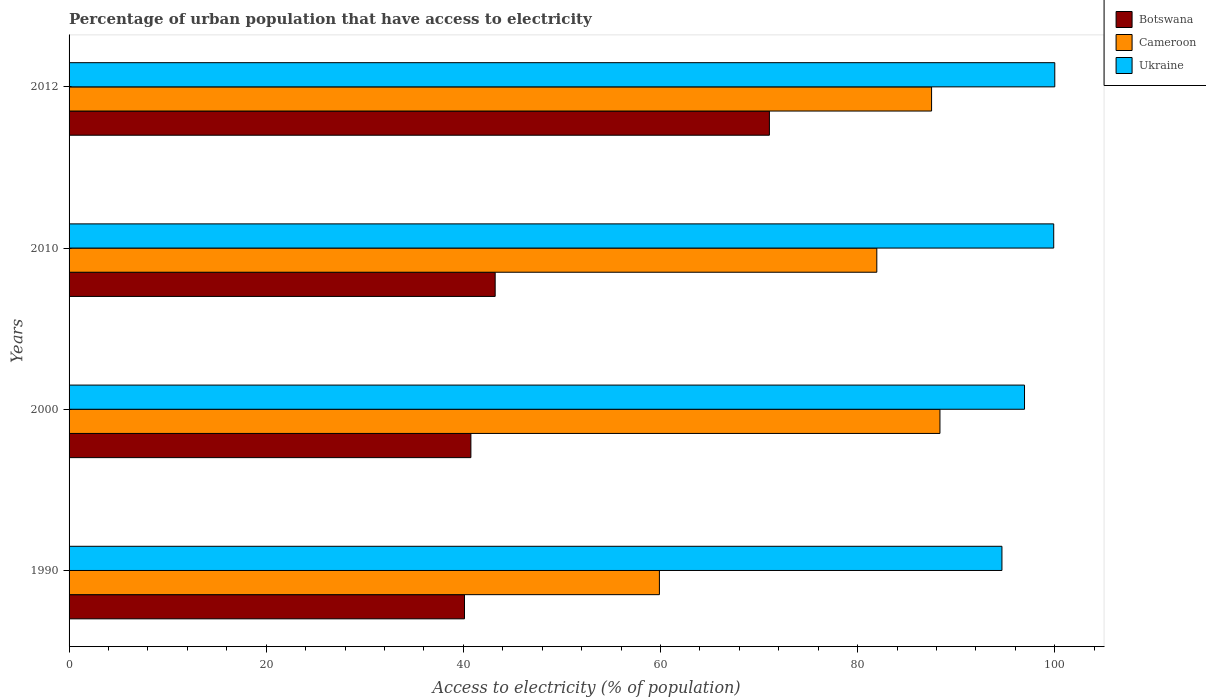Are the number of bars on each tick of the Y-axis equal?
Offer a very short reply. Yes. How many bars are there on the 3rd tick from the top?
Provide a short and direct response. 3. How many bars are there on the 4th tick from the bottom?
Offer a very short reply. 3. What is the percentage of urban population that have access to electricity in Botswana in 2012?
Offer a very short reply. 71.05. Across all years, what is the maximum percentage of urban population that have access to electricity in Botswana?
Provide a short and direct response. 71.05. Across all years, what is the minimum percentage of urban population that have access to electricity in Ukraine?
Offer a very short reply. 94.64. In which year was the percentage of urban population that have access to electricity in Botswana maximum?
Keep it short and to the point. 2012. In which year was the percentage of urban population that have access to electricity in Ukraine minimum?
Your answer should be very brief. 1990. What is the total percentage of urban population that have access to electricity in Ukraine in the graph?
Make the answer very short. 391.46. What is the difference between the percentage of urban population that have access to electricity in Cameroon in 2000 and that in 2010?
Keep it short and to the point. 6.41. What is the difference between the percentage of urban population that have access to electricity in Botswana in 1990 and the percentage of urban population that have access to electricity in Ukraine in 2010?
Offer a very short reply. -59.78. What is the average percentage of urban population that have access to electricity in Botswana per year?
Your response must be concise. 48.79. In the year 2000, what is the difference between the percentage of urban population that have access to electricity in Ukraine and percentage of urban population that have access to electricity in Botswana?
Offer a very short reply. 56.16. In how many years, is the percentage of urban population that have access to electricity in Botswana greater than 60 %?
Provide a short and direct response. 1. What is the ratio of the percentage of urban population that have access to electricity in Ukraine in 2000 to that in 2010?
Offer a terse response. 0.97. Is the percentage of urban population that have access to electricity in Botswana in 1990 less than that in 2000?
Your answer should be very brief. Yes. Is the difference between the percentage of urban population that have access to electricity in Ukraine in 2010 and 2012 greater than the difference between the percentage of urban population that have access to electricity in Botswana in 2010 and 2012?
Offer a very short reply. Yes. What is the difference between the highest and the second highest percentage of urban population that have access to electricity in Cameroon?
Provide a succinct answer. 0.85. What is the difference between the highest and the lowest percentage of urban population that have access to electricity in Cameroon?
Keep it short and to the point. 28.46. Is the sum of the percentage of urban population that have access to electricity in Ukraine in 2000 and 2012 greater than the maximum percentage of urban population that have access to electricity in Botswana across all years?
Provide a succinct answer. Yes. What does the 3rd bar from the top in 1990 represents?
Give a very brief answer. Botswana. What does the 2nd bar from the bottom in 2010 represents?
Your answer should be very brief. Cameroon. Are all the bars in the graph horizontal?
Your response must be concise. Yes. How many years are there in the graph?
Make the answer very short. 4. What is the difference between two consecutive major ticks on the X-axis?
Provide a succinct answer. 20. Does the graph contain any zero values?
Keep it short and to the point. No. Where does the legend appear in the graph?
Your answer should be compact. Top right. How many legend labels are there?
Offer a very short reply. 3. How are the legend labels stacked?
Your answer should be very brief. Vertical. What is the title of the graph?
Keep it short and to the point. Percentage of urban population that have access to electricity. Does "Morocco" appear as one of the legend labels in the graph?
Offer a very short reply. No. What is the label or title of the X-axis?
Provide a succinct answer. Access to electricity (% of population). What is the Access to electricity (% of population) of Botswana in 1990?
Your response must be concise. 40.12. What is the Access to electricity (% of population) of Cameroon in 1990?
Your answer should be very brief. 59.89. What is the Access to electricity (% of population) in Ukraine in 1990?
Provide a short and direct response. 94.64. What is the Access to electricity (% of population) of Botswana in 2000?
Provide a succinct answer. 40.76. What is the Access to electricity (% of population) of Cameroon in 2000?
Ensure brevity in your answer.  88.35. What is the Access to electricity (% of population) of Ukraine in 2000?
Offer a terse response. 96.93. What is the Access to electricity (% of population) of Botswana in 2010?
Provide a succinct answer. 43.23. What is the Access to electricity (% of population) of Cameroon in 2010?
Your answer should be very brief. 81.95. What is the Access to electricity (% of population) of Ukraine in 2010?
Make the answer very short. 99.89. What is the Access to electricity (% of population) of Botswana in 2012?
Ensure brevity in your answer.  71.05. What is the Access to electricity (% of population) of Cameroon in 2012?
Offer a terse response. 87.5. Across all years, what is the maximum Access to electricity (% of population) in Botswana?
Offer a terse response. 71.05. Across all years, what is the maximum Access to electricity (% of population) in Cameroon?
Offer a terse response. 88.35. Across all years, what is the maximum Access to electricity (% of population) of Ukraine?
Keep it short and to the point. 100. Across all years, what is the minimum Access to electricity (% of population) in Botswana?
Your answer should be compact. 40.12. Across all years, what is the minimum Access to electricity (% of population) of Cameroon?
Offer a terse response. 59.89. Across all years, what is the minimum Access to electricity (% of population) in Ukraine?
Ensure brevity in your answer.  94.64. What is the total Access to electricity (% of population) in Botswana in the graph?
Keep it short and to the point. 195.16. What is the total Access to electricity (% of population) of Cameroon in the graph?
Offer a terse response. 317.68. What is the total Access to electricity (% of population) of Ukraine in the graph?
Provide a short and direct response. 391.46. What is the difference between the Access to electricity (% of population) of Botswana in 1990 and that in 2000?
Your answer should be very brief. -0.65. What is the difference between the Access to electricity (% of population) in Cameroon in 1990 and that in 2000?
Keep it short and to the point. -28.46. What is the difference between the Access to electricity (% of population) of Ukraine in 1990 and that in 2000?
Keep it short and to the point. -2.29. What is the difference between the Access to electricity (% of population) of Botswana in 1990 and that in 2010?
Ensure brevity in your answer.  -3.11. What is the difference between the Access to electricity (% of population) of Cameroon in 1990 and that in 2010?
Give a very brief answer. -22.06. What is the difference between the Access to electricity (% of population) in Ukraine in 1990 and that in 2010?
Provide a succinct answer. -5.25. What is the difference between the Access to electricity (% of population) of Botswana in 1990 and that in 2012?
Offer a terse response. -30.93. What is the difference between the Access to electricity (% of population) in Cameroon in 1990 and that in 2012?
Make the answer very short. -27.61. What is the difference between the Access to electricity (% of population) in Ukraine in 1990 and that in 2012?
Your answer should be compact. -5.36. What is the difference between the Access to electricity (% of population) of Botswana in 2000 and that in 2010?
Your answer should be compact. -2.46. What is the difference between the Access to electricity (% of population) in Cameroon in 2000 and that in 2010?
Your answer should be very brief. 6.41. What is the difference between the Access to electricity (% of population) of Ukraine in 2000 and that in 2010?
Provide a succinct answer. -2.96. What is the difference between the Access to electricity (% of population) in Botswana in 2000 and that in 2012?
Your answer should be compact. -30.28. What is the difference between the Access to electricity (% of population) of Cameroon in 2000 and that in 2012?
Give a very brief answer. 0.85. What is the difference between the Access to electricity (% of population) of Ukraine in 2000 and that in 2012?
Give a very brief answer. -3.07. What is the difference between the Access to electricity (% of population) of Botswana in 2010 and that in 2012?
Ensure brevity in your answer.  -27.82. What is the difference between the Access to electricity (% of population) of Cameroon in 2010 and that in 2012?
Make the answer very short. -5.55. What is the difference between the Access to electricity (% of population) in Ukraine in 2010 and that in 2012?
Your response must be concise. -0.11. What is the difference between the Access to electricity (% of population) of Botswana in 1990 and the Access to electricity (% of population) of Cameroon in 2000?
Give a very brief answer. -48.23. What is the difference between the Access to electricity (% of population) in Botswana in 1990 and the Access to electricity (% of population) in Ukraine in 2000?
Offer a terse response. -56.81. What is the difference between the Access to electricity (% of population) in Cameroon in 1990 and the Access to electricity (% of population) in Ukraine in 2000?
Provide a succinct answer. -37.04. What is the difference between the Access to electricity (% of population) in Botswana in 1990 and the Access to electricity (% of population) in Cameroon in 2010?
Provide a succinct answer. -41.83. What is the difference between the Access to electricity (% of population) of Botswana in 1990 and the Access to electricity (% of population) of Ukraine in 2010?
Offer a terse response. -59.78. What is the difference between the Access to electricity (% of population) in Cameroon in 1990 and the Access to electricity (% of population) in Ukraine in 2010?
Your response must be concise. -40. What is the difference between the Access to electricity (% of population) in Botswana in 1990 and the Access to electricity (% of population) in Cameroon in 2012?
Offer a terse response. -47.38. What is the difference between the Access to electricity (% of population) of Botswana in 1990 and the Access to electricity (% of population) of Ukraine in 2012?
Your answer should be compact. -59.88. What is the difference between the Access to electricity (% of population) in Cameroon in 1990 and the Access to electricity (% of population) in Ukraine in 2012?
Make the answer very short. -40.11. What is the difference between the Access to electricity (% of population) of Botswana in 2000 and the Access to electricity (% of population) of Cameroon in 2010?
Offer a terse response. -41.18. What is the difference between the Access to electricity (% of population) of Botswana in 2000 and the Access to electricity (% of population) of Ukraine in 2010?
Provide a succinct answer. -59.13. What is the difference between the Access to electricity (% of population) in Cameroon in 2000 and the Access to electricity (% of population) in Ukraine in 2010?
Ensure brevity in your answer.  -11.54. What is the difference between the Access to electricity (% of population) in Botswana in 2000 and the Access to electricity (% of population) in Cameroon in 2012?
Your answer should be very brief. -46.74. What is the difference between the Access to electricity (% of population) of Botswana in 2000 and the Access to electricity (% of population) of Ukraine in 2012?
Offer a terse response. -59.24. What is the difference between the Access to electricity (% of population) in Cameroon in 2000 and the Access to electricity (% of population) in Ukraine in 2012?
Make the answer very short. -11.65. What is the difference between the Access to electricity (% of population) in Botswana in 2010 and the Access to electricity (% of population) in Cameroon in 2012?
Make the answer very short. -44.27. What is the difference between the Access to electricity (% of population) in Botswana in 2010 and the Access to electricity (% of population) in Ukraine in 2012?
Provide a succinct answer. -56.77. What is the difference between the Access to electricity (% of population) in Cameroon in 2010 and the Access to electricity (% of population) in Ukraine in 2012?
Keep it short and to the point. -18.05. What is the average Access to electricity (% of population) in Botswana per year?
Keep it short and to the point. 48.79. What is the average Access to electricity (% of population) of Cameroon per year?
Offer a very short reply. 79.42. What is the average Access to electricity (% of population) in Ukraine per year?
Your answer should be compact. 97.86. In the year 1990, what is the difference between the Access to electricity (% of population) of Botswana and Access to electricity (% of population) of Cameroon?
Your answer should be very brief. -19.77. In the year 1990, what is the difference between the Access to electricity (% of population) in Botswana and Access to electricity (% of population) in Ukraine?
Keep it short and to the point. -54.52. In the year 1990, what is the difference between the Access to electricity (% of population) in Cameroon and Access to electricity (% of population) in Ukraine?
Keep it short and to the point. -34.75. In the year 2000, what is the difference between the Access to electricity (% of population) of Botswana and Access to electricity (% of population) of Cameroon?
Give a very brief answer. -47.59. In the year 2000, what is the difference between the Access to electricity (% of population) in Botswana and Access to electricity (% of population) in Ukraine?
Your answer should be compact. -56.16. In the year 2000, what is the difference between the Access to electricity (% of population) of Cameroon and Access to electricity (% of population) of Ukraine?
Your answer should be compact. -8.58. In the year 2010, what is the difference between the Access to electricity (% of population) in Botswana and Access to electricity (% of population) in Cameroon?
Offer a terse response. -38.72. In the year 2010, what is the difference between the Access to electricity (% of population) of Botswana and Access to electricity (% of population) of Ukraine?
Offer a terse response. -56.66. In the year 2010, what is the difference between the Access to electricity (% of population) in Cameroon and Access to electricity (% of population) in Ukraine?
Provide a succinct answer. -17.95. In the year 2012, what is the difference between the Access to electricity (% of population) of Botswana and Access to electricity (% of population) of Cameroon?
Your response must be concise. -16.45. In the year 2012, what is the difference between the Access to electricity (% of population) in Botswana and Access to electricity (% of population) in Ukraine?
Offer a very short reply. -28.95. What is the ratio of the Access to electricity (% of population) in Botswana in 1990 to that in 2000?
Your answer should be compact. 0.98. What is the ratio of the Access to electricity (% of population) in Cameroon in 1990 to that in 2000?
Provide a succinct answer. 0.68. What is the ratio of the Access to electricity (% of population) of Ukraine in 1990 to that in 2000?
Give a very brief answer. 0.98. What is the ratio of the Access to electricity (% of population) in Botswana in 1990 to that in 2010?
Your response must be concise. 0.93. What is the ratio of the Access to electricity (% of population) of Cameroon in 1990 to that in 2010?
Offer a very short reply. 0.73. What is the ratio of the Access to electricity (% of population) of Ukraine in 1990 to that in 2010?
Make the answer very short. 0.95. What is the ratio of the Access to electricity (% of population) in Botswana in 1990 to that in 2012?
Ensure brevity in your answer.  0.56. What is the ratio of the Access to electricity (% of population) in Cameroon in 1990 to that in 2012?
Make the answer very short. 0.68. What is the ratio of the Access to electricity (% of population) of Ukraine in 1990 to that in 2012?
Provide a succinct answer. 0.95. What is the ratio of the Access to electricity (% of population) of Botswana in 2000 to that in 2010?
Provide a short and direct response. 0.94. What is the ratio of the Access to electricity (% of population) in Cameroon in 2000 to that in 2010?
Give a very brief answer. 1.08. What is the ratio of the Access to electricity (% of population) of Ukraine in 2000 to that in 2010?
Give a very brief answer. 0.97. What is the ratio of the Access to electricity (% of population) of Botswana in 2000 to that in 2012?
Your response must be concise. 0.57. What is the ratio of the Access to electricity (% of population) of Cameroon in 2000 to that in 2012?
Your answer should be compact. 1.01. What is the ratio of the Access to electricity (% of population) in Ukraine in 2000 to that in 2012?
Provide a short and direct response. 0.97. What is the ratio of the Access to electricity (% of population) in Botswana in 2010 to that in 2012?
Offer a very short reply. 0.61. What is the ratio of the Access to electricity (% of population) in Cameroon in 2010 to that in 2012?
Keep it short and to the point. 0.94. What is the ratio of the Access to electricity (% of population) in Ukraine in 2010 to that in 2012?
Offer a terse response. 1. What is the difference between the highest and the second highest Access to electricity (% of population) of Botswana?
Give a very brief answer. 27.82. What is the difference between the highest and the second highest Access to electricity (% of population) of Cameroon?
Give a very brief answer. 0.85. What is the difference between the highest and the second highest Access to electricity (% of population) in Ukraine?
Your answer should be very brief. 0.11. What is the difference between the highest and the lowest Access to electricity (% of population) of Botswana?
Your response must be concise. 30.93. What is the difference between the highest and the lowest Access to electricity (% of population) in Cameroon?
Make the answer very short. 28.46. What is the difference between the highest and the lowest Access to electricity (% of population) of Ukraine?
Your answer should be compact. 5.36. 